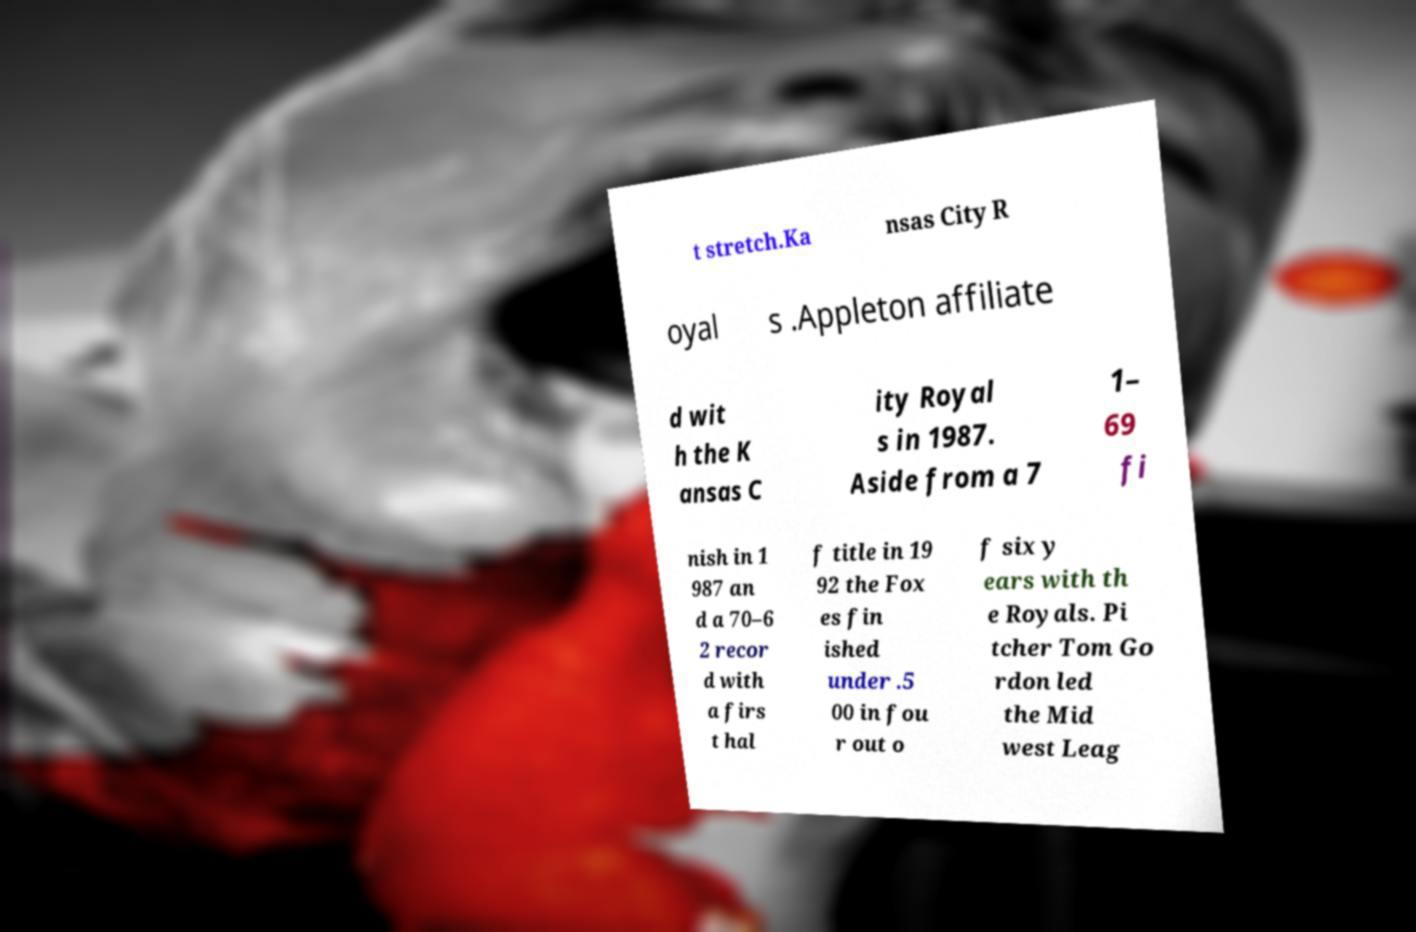Please identify and transcribe the text found in this image. t stretch.Ka nsas City R oyal s .Appleton affiliate d wit h the K ansas C ity Royal s in 1987. Aside from a 7 1– 69 fi nish in 1 987 an d a 70–6 2 recor d with a firs t hal f title in 19 92 the Fox es fin ished under .5 00 in fou r out o f six y ears with th e Royals. Pi tcher Tom Go rdon led the Mid west Leag 